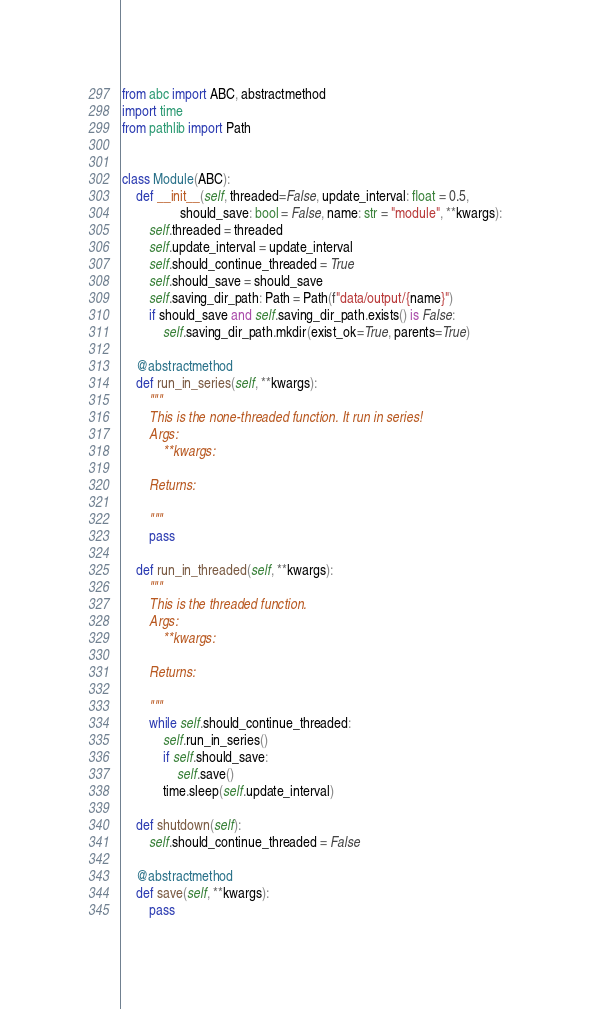Convert code to text. <code><loc_0><loc_0><loc_500><loc_500><_Python_>from abc import ABC, abstractmethod
import time
from pathlib import Path


class Module(ABC):
    def __init__(self, threaded=False, update_interval: float = 0.5,
                 should_save: bool = False, name: str = "module", **kwargs):
        self.threaded = threaded
        self.update_interval = update_interval
        self.should_continue_threaded = True
        self.should_save = should_save
        self.saving_dir_path: Path = Path(f"data/output/{name}")
        if should_save and self.saving_dir_path.exists() is False:
            self.saving_dir_path.mkdir(exist_ok=True, parents=True)

    @abstractmethod
    def run_in_series(self, **kwargs):
        """
        This is the none-threaded function. It run in series!
        Args:
            **kwargs:

        Returns:

        """
        pass

    def run_in_threaded(self, **kwargs):
        """
        This is the threaded function.
        Args:
            **kwargs:

        Returns:

        """
        while self.should_continue_threaded:
            self.run_in_series()
            if self.should_save:
                self.save()
            time.sleep(self.update_interval)

    def shutdown(self):
        self.should_continue_threaded = False

    @abstractmethod
    def save(self, **kwargs):
        pass
</code> 